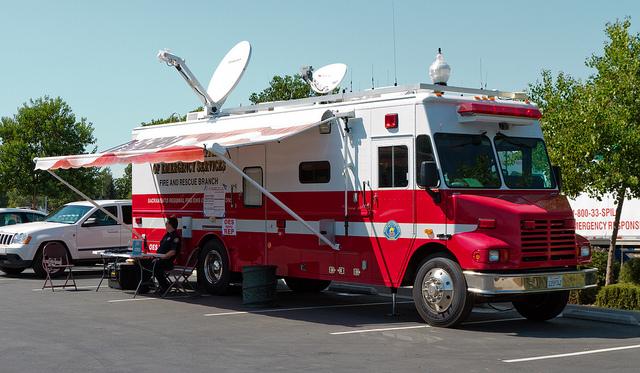Does the truck have a license plate?
Short answer required. Yes. How many satellites does this truck have?
Give a very brief answer. 2. What kind of vehicle is parked next to the truck?
Quick response, please. Jeep. 